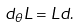<formula> <loc_0><loc_0><loc_500><loc_500>d _ { \theta } L = L d .</formula> 